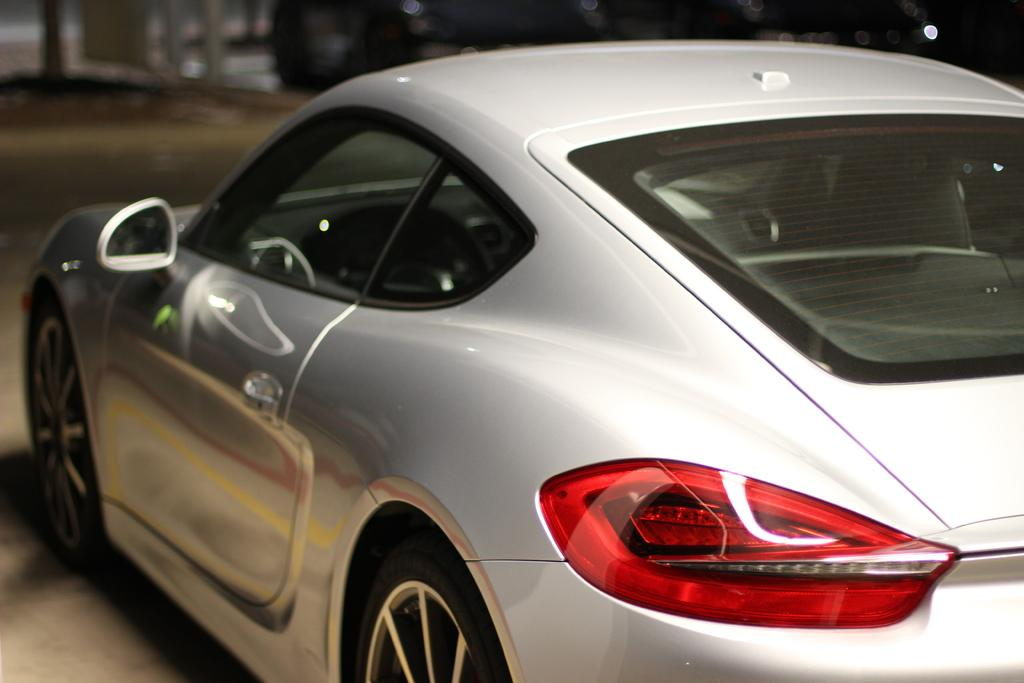What is the main subject of the image? There is a vehicle on the ground in the image. Can you describe the background of the image? There are pillars visible in the background of the image. What type of tray is being used to process the print in the image? There is no tray, process, or print present in the image. 